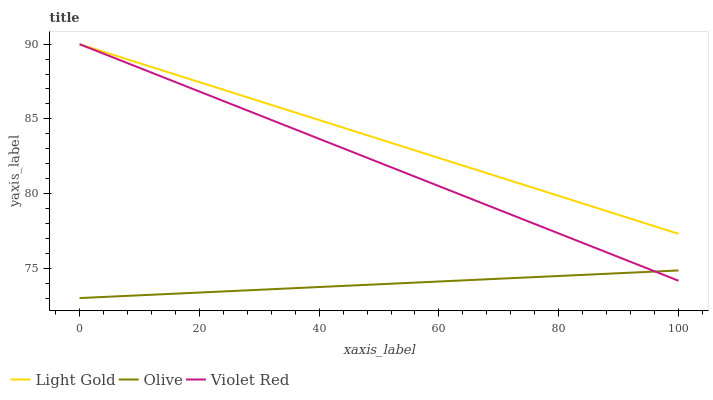Does Olive have the minimum area under the curve?
Answer yes or no. Yes. Does Light Gold have the maximum area under the curve?
Answer yes or no. Yes. Does Violet Red have the minimum area under the curve?
Answer yes or no. No. Does Violet Red have the maximum area under the curve?
Answer yes or no. No. Is Light Gold the smoothest?
Answer yes or no. Yes. Is Violet Red the roughest?
Answer yes or no. Yes. Is Violet Red the smoothest?
Answer yes or no. No. Is Light Gold the roughest?
Answer yes or no. No. Does Olive have the lowest value?
Answer yes or no. Yes. Does Violet Red have the lowest value?
Answer yes or no. No. Does Light Gold have the highest value?
Answer yes or no. Yes. Is Olive less than Light Gold?
Answer yes or no. Yes. Is Light Gold greater than Olive?
Answer yes or no. Yes. Does Olive intersect Violet Red?
Answer yes or no. Yes. Is Olive less than Violet Red?
Answer yes or no. No. Is Olive greater than Violet Red?
Answer yes or no. No. Does Olive intersect Light Gold?
Answer yes or no. No. 